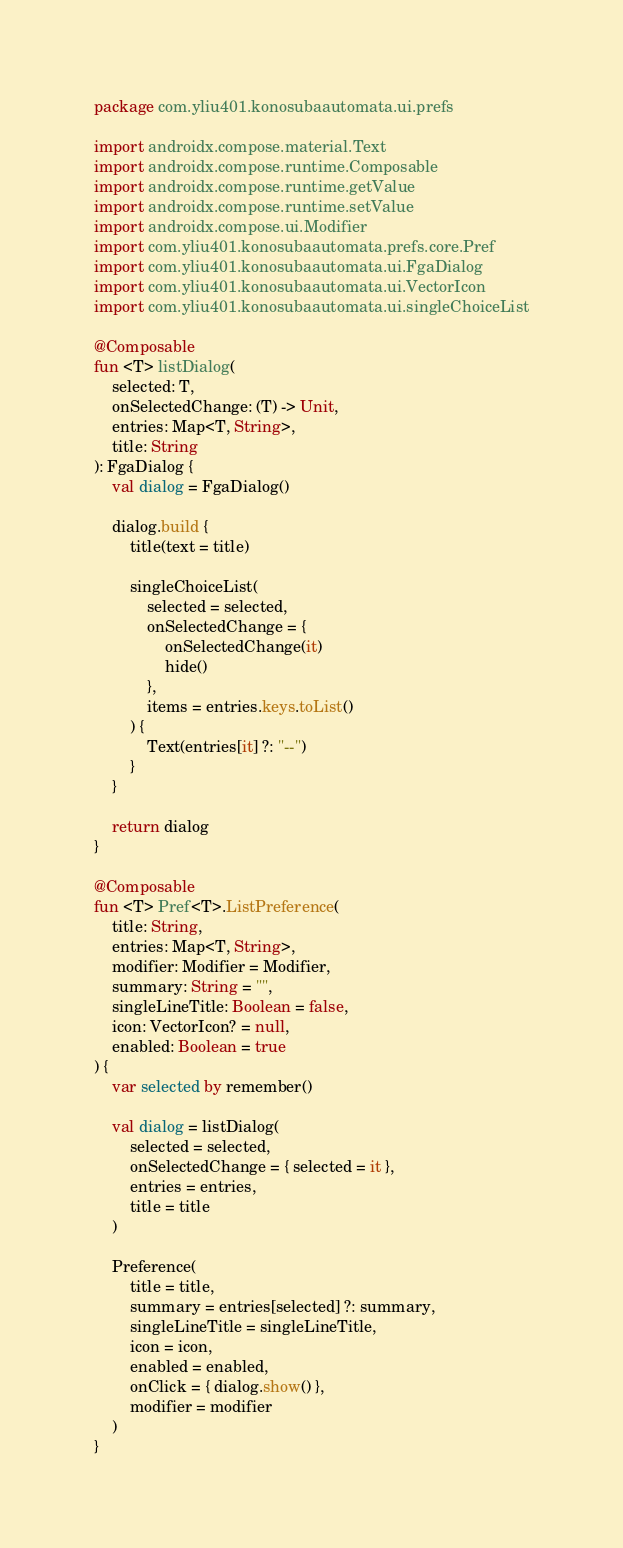<code> <loc_0><loc_0><loc_500><loc_500><_Kotlin_>package com.yliu401.konosubaautomata.ui.prefs

import androidx.compose.material.Text
import androidx.compose.runtime.Composable
import androidx.compose.runtime.getValue
import androidx.compose.runtime.setValue
import androidx.compose.ui.Modifier
import com.yliu401.konosubaautomata.prefs.core.Pref
import com.yliu401.konosubaautomata.ui.FgaDialog
import com.yliu401.konosubaautomata.ui.VectorIcon
import com.yliu401.konosubaautomata.ui.singleChoiceList

@Composable
fun <T> listDialog(
    selected: T,
    onSelectedChange: (T) -> Unit,
    entries: Map<T, String>,
    title: String
): FgaDialog {
    val dialog = FgaDialog()

    dialog.build {
        title(text = title)

        singleChoiceList(
            selected = selected,
            onSelectedChange = {
                onSelectedChange(it)
                hide()
            },
            items = entries.keys.toList()
        ) {
            Text(entries[it] ?: "--")
        }
    }

    return dialog
}

@Composable
fun <T> Pref<T>.ListPreference(
    title: String,
    entries: Map<T, String>,
    modifier: Modifier = Modifier,
    summary: String = "",
    singleLineTitle: Boolean = false,
    icon: VectorIcon? = null,
    enabled: Boolean = true
) {
    var selected by remember()

    val dialog = listDialog(
        selected = selected,
        onSelectedChange = { selected = it },
        entries = entries,
        title = title
    )

    Preference(
        title = title,
        summary = entries[selected] ?: summary,
        singleLineTitle = singleLineTitle,
        icon = icon,
        enabled = enabled,
        onClick = { dialog.show() },
        modifier = modifier
    )
}</code> 